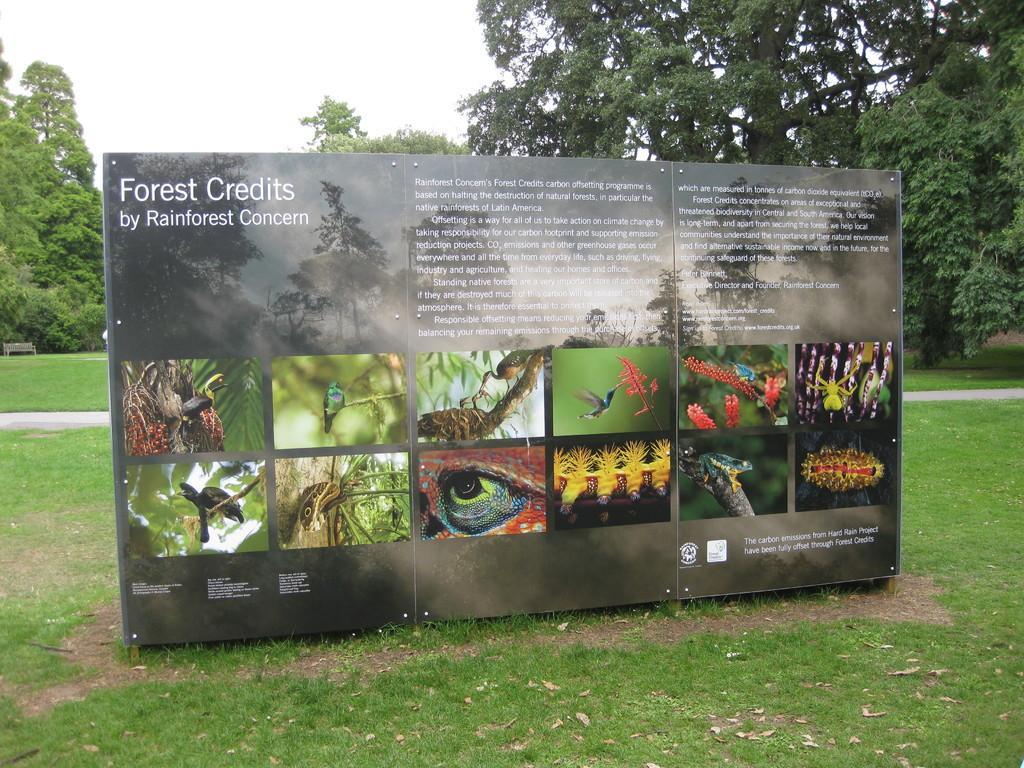Can you describe this image briefly? In this image there is a board with text and images placed on the grass. In the background we can see trees. Sky is also visible. 